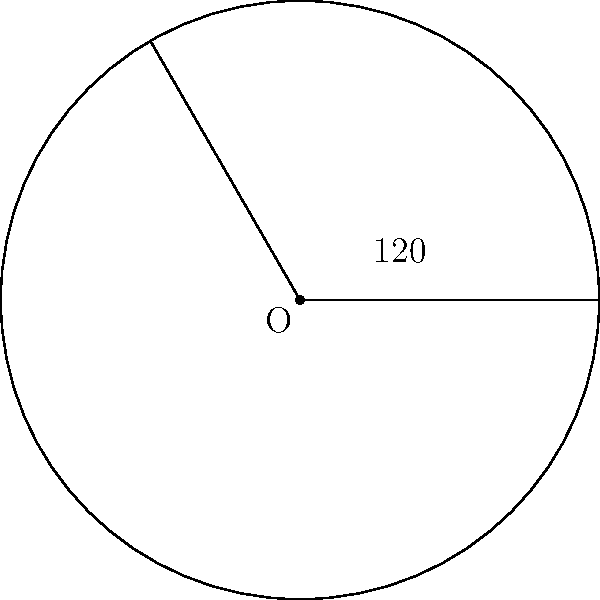As a singer-songwriter who understands the importance of precision in music and geometry, imagine you're designing a circular stage for your next online concert. The stage has a radius of 5 meters, and you want to dedicate a sector of 120° for your band members. Calculate the area of this sector where your bandmates will perform. Round your answer to two decimal places. Let's approach this step-by-step, like composing a song:

1) The formula for the area of a circular sector is:

   $$A = \frac{\theta}{360°} \cdot \pi r^2$$

   Where $\theta$ is the central angle in degrees, and $r$ is the radius.

2) We're given:
   - Radius $(r) = 5$ meters
   - Central angle $(\theta) = 120°$

3) Let's substitute these values into our formula:

   $$A = \frac{120°}{360°} \cdot \pi \cdot 5^2$$

4) Simplify the fraction:

   $$A = \frac{1}{3} \cdot \pi \cdot 25$$

5) Calculate:

   $$A = \frac{25\pi}{3} \approx 26.18 \text{ m}^2$$

6) Rounding to two decimal places:

   $$A \approx 26.18 \text{ m}^2$$

Just as we fine-tune our musical arrangements, we've precisely calculated the area for your band's performance space!
Answer: 26.18 m² 